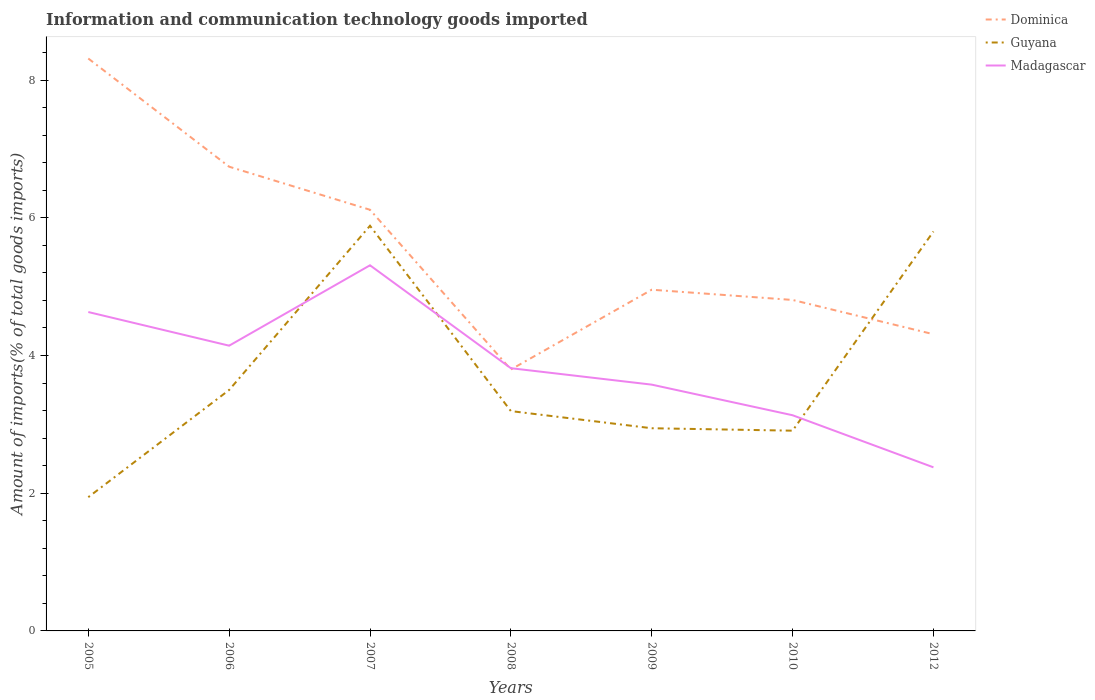How many different coloured lines are there?
Ensure brevity in your answer.  3. Is the number of lines equal to the number of legend labels?
Make the answer very short. Yes. Across all years, what is the maximum amount of goods imported in Madagascar?
Offer a very short reply. 2.38. What is the total amount of goods imported in Madagascar in the graph?
Your answer should be very brief. 1.05. What is the difference between the highest and the second highest amount of goods imported in Guyana?
Make the answer very short. 3.94. What is the difference between the highest and the lowest amount of goods imported in Madagascar?
Keep it short and to the point. 3. How many years are there in the graph?
Provide a short and direct response. 7. What is the difference between two consecutive major ticks on the Y-axis?
Offer a very short reply. 2. Are the values on the major ticks of Y-axis written in scientific E-notation?
Make the answer very short. No. Does the graph contain any zero values?
Provide a short and direct response. No. Does the graph contain grids?
Offer a terse response. No. Where does the legend appear in the graph?
Give a very brief answer. Top right. How are the legend labels stacked?
Offer a terse response. Vertical. What is the title of the graph?
Your answer should be very brief. Information and communication technology goods imported. Does "United States" appear as one of the legend labels in the graph?
Provide a short and direct response. No. What is the label or title of the Y-axis?
Offer a very short reply. Amount of imports(% of total goods imports). What is the Amount of imports(% of total goods imports) of Dominica in 2005?
Offer a terse response. 8.31. What is the Amount of imports(% of total goods imports) in Guyana in 2005?
Give a very brief answer. 1.94. What is the Amount of imports(% of total goods imports) of Madagascar in 2005?
Your answer should be compact. 4.63. What is the Amount of imports(% of total goods imports) of Dominica in 2006?
Make the answer very short. 6.74. What is the Amount of imports(% of total goods imports) in Guyana in 2006?
Offer a very short reply. 3.5. What is the Amount of imports(% of total goods imports) in Madagascar in 2006?
Offer a very short reply. 4.14. What is the Amount of imports(% of total goods imports) in Dominica in 2007?
Offer a very short reply. 6.12. What is the Amount of imports(% of total goods imports) in Guyana in 2007?
Offer a very short reply. 5.88. What is the Amount of imports(% of total goods imports) of Madagascar in 2007?
Your response must be concise. 5.31. What is the Amount of imports(% of total goods imports) of Dominica in 2008?
Keep it short and to the point. 3.8. What is the Amount of imports(% of total goods imports) in Guyana in 2008?
Your response must be concise. 3.19. What is the Amount of imports(% of total goods imports) in Madagascar in 2008?
Provide a succinct answer. 3.82. What is the Amount of imports(% of total goods imports) of Dominica in 2009?
Offer a terse response. 4.95. What is the Amount of imports(% of total goods imports) of Guyana in 2009?
Your answer should be very brief. 2.94. What is the Amount of imports(% of total goods imports) in Madagascar in 2009?
Give a very brief answer. 3.58. What is the Amount of imports(% of total goods imports) in Dominica in 2010?
Provide a succinct answer. 4.81. What is the Amount of imports(% of total goods imports) of Guyana in 2010?
Offer a very short reply. 2.91. What is the Amount of imports(% of total goods imports) in Madagascar in 2010?
Offer a very short reply. 3.13. What is the Amount of imports(% of total goods imports) in Dominica in 2012?
Offer a terse response. 4.31. What is the Amount of imports(% of total goods imports) in Guyana in 2012?
Your response must be concise. 5.8. What is the Amount of imports(% of total goods imports) in Madagascar in 2012?
Make the answer very short. 2.38. Across all years, what is the maximum Amount of imports(% of total goods imports) of Dominica?
Your answer should be very brief. 8.31. Across all years, what is the maximum Amount of imports(% of total goods imports) of Guyana?
Offer a very short reply. 5.88. Across all years, what is the maximum Amount of imports(% of total goods imports) of Madagascar?
Your answer should be very brief. 5.31. Across all years, what is the minimum Amount of imports(% of total goods imports) of Dominica?
Your response must be concise. 3.8. Across all years, what is the minimum Amount of imports(% of total goods imports) of Guyana?
Keep it short and to the point. 1.94. Across all years, what is the minimum Amount of imports(% of total goods imports) of Madagascar?
Offer a terse response. 2.38. What is the total Amount of imports(% of total goods imports) in Dominica in the graph?
Make the answer very short. 39.04. What is the total Amount of imports(% of total goods imports) in Guyana in the graph?
Offer a very short reply. 26.17. What is the total Amount of imports(% of total goods imports) of Madagascar in the graph?
Make the answer very short. 26.98. What is the difference between the Amount of imports(% of total goods imports) in Dominica in 2005 and that in 2006?
Your response must be concise. 1.57. What is the difference between the Amount of imports(% of total goods imports) in Guyana in 2005 and that in 2006?
Keep it short and to the point. -1.56. What is the difference between the Amount of imports(% of total goods imports) in Madagascar in 2005 and that in 2006?
Give a very brief answer. 0.49. What is the difference between the Amount of imports(% of total goods imports) of Dominica in 2005 and that in 2007?
Offer a terse response. 2.2. What is the difference between the Amount of imports(% of total goods imports) in Guyana in 2005 and that in 2007?
Keep it short and to the point. -3.94. What is the difference between the Amount of imports(% of total goods imports) in Madagascar in 2005 and that in 2007?
Make the answer very short. -0.68. What is the difference between the Amount of imports(% of total goods imports) in Dominica in 2005 and that in 2008?
Offer a terse response. 4.52. What is the difference between the Amount of imports(% of total goods imports) in Guyana in 2005 and that in 2008?
Provide a short and direct response. -1.25. What is the difference between the Amount of imports(% of total goods imports) of Madagascar in 2005 and that in 2008?
Offer a very short reply. 0.82. What is the difference between the Amount of imports(% of total goods imports) of Dominica in 2005 and that in 2009?
Ensure brevity in your answer.  3.36. What is the difference between the Amount of imports(% of total goods imports) of Guyana in 2005 and that in 2009?
Provide a succinct answer. -1. What is the difference between the Amount of imports(% of total goods imports) in Madagascar in 2005 and that in 2009?
Your answer should be very brief. 1.05. What is the difference between the Amount of imports(% of total goods imports) in Dominica in 2005 and that in 2010?
Your answer should be very brief. 3.51. What is the difference between the Amount of imports(% of total goods imports) of Guyana in 2005 and that in 2010?
Make the answer very short. -0.97. What is the difference between the Amount of imports(% of total goods imports) of Madagascar in 2005 and that in 2010?
Keep it short and to the point. 1.5. What is the difference between the Amount of imports(% of total goods imports) in Dominica in 2005 and that in 2012?
Your answer should be compact. 4. What is the difference between the Amount of imports(% of total goods imports) in Guyana in 2005 and that in 2012?
Your response must be concise. -3.86. What is the difference between the Amount of imports(% of total goods imports) in Madagascar in 2005 and that in 2012?
Provide a succinct answer. 2.26. What is the difference between the Amount of imports(% of total goods imports) in Dominica in 2006 and that in 2007?
Keep it short and to the point. 0.63. What is the difference between the Amount of imports(% of total goods imports) of Guyana in 2006 and that in 2007?
Make the answer very short. -2.38. What is the difference between the Amount of imports(% of total goods imports) of Madagascar in 2006 and that in 2007?
Make the answer very short. -1.17. What is the difference between the Amount of imports(% of total goods imports) of Dominica in 2006 and that in 2008?
Keep it short and to the point. 2.95. What is the difference between the Amount of imports(% of total goods imports) of Guyana in 2006 and that in 2008?
Your answer should be compact. 0.31. What is the difference between the Amount of imports(% of total goods imports) of Madagascar in 2006 and that in 2008?
Offer a terse response. 0.33. What is the difference between the Amount of imports(% of total goods imports) of Dominica in 2006 and that in 2009?
Keep it short and to the point. 1.79. What is the difference between the Amount of imports(% of total goods imports) of Guyana in 2006 and that in 2009?
Ensure brevity in your answer.  0.56. What is the difference between the Amount of imports(% of total goods imports) in Madagascar in 2006 and that in 2009?
Keep it short and to the point. 0.57. What is the difference between the Amount of imports(% of total goods imports) in Dominica in 2006 and that in 2010?
Your response must be concise. 1.94. What is the difference between the Amount of imports(% of total goods imports) in Guyana in 2006 and that in 2010?
Give a very brief answer. 0.59. What is the difference between the Amount of imports(% of total goods imports) of Madagascar in 2006 and that in 2010?
Ensure brevity in your answer.  1.01. What is the difference between the Amount of imports(% of total goods imports) in Dominica in 2006 and that in 2012?
Offer a terse response. 2.43. What is the difference between the Amount of imports(% of total goods imports) of Guyana in 2006 and that in 2012?
Give a very brief answer. -2.3. What is the difference between the Amount of imports(% of total goods imports) of Madagascar in 2006 and that in 2012?
Provide a succinct answer. 1.77. What is the difference between the Amount of imports(% of total goods imports) in Dominica in 2007 and that in 2008?
Provide a short and direct response. 2.32. What is the difference between the Amount of imports(% of total goods imports) of Guyana in 2007 and that in 2008?
Your response must be concise. 2.69. What is the difference between the Amount of imports(% of total goods imports) in Madagascar in 2007 and that in 2008?
Your response must be concise. 1.49. What is the difference between the Amount of imports(% of total goods imports) in Dominica in 2007 and that in 2009?
Keep it short and to the point. 1.16. What is the difference between the Amount of imports(% of total goods imports) in Guyana in 2007 and that in 2009?
Give a very brief answer. 2.94. What is the difference between the Amount of imports(% of total goods imports) in Madagascar in 2007 and that in 2009?
Make the answer very short. 1.73. What is the difference between the Amount of imports(% of total goods imports) of Dominica in 2007 and that in 2010?
Give a very brief answer. 1.31. What is the difference between the Amount of imports(% of total goods imports) of Guyana in 2007 and that in 2010?
Offer a terse response. 2.98. What is the difference between the Amount of imports(% of total goods imports) of Madagascar in 2007 and that in 2010?
Make the answer very short. 2.18. What is the difference between the Amount of imports(% of total goods imports) of Dominica in 2007 and that in 2012?
Your answer should be very brief. 1.81. What is the difference between the Amount of imports(% of total goods imports) of Guyana in 2007 and that in 2012?
Provide a succinct answer. 0.08. What is the difference between the Amount of imports(% of total goods imports) in Madagascar in 2007 and that in 2012?
Give a very brief answer. 2.93. What is the difference between the Amount of imports(% of total goods imports) of Dominica in 2008 and that in 2009?
Offer a very short reply. -1.16. What is the difference between the Amount of imports(% of total goods imports) of Guyana in 2008 and that in 2009?
Offer a very short reply. 0.25. What is the difference between the Amount of imports(% of total goods imports) of Madagascar in 2008 and that in 2009?
Provide a short and direct response. 0.24. What is the difference between the Amount of imports(% of total goods imports) of Dominica in 2008 and that in 2010?
Give a very brief answer. -1.01. What is the difference between the Amount of imports(% of total goods imports) in Guyana in 2008 and that in 2010?
Make the answer very short. 0.28. What is the difference between the Amount of imports(% of total goods imports) in Madagascar in 2008 and that in 2010?
Provide a succinct answer. 0.68. What is the difference between the Amount of imports(% of total goods imports) in Dominica in 2008 and that in 2012?
Give a very brief answer. -0.51. What is the difference between the Amount of imports(% of total goods imports) of Guyana in 2008 and that in 2012?
Offer a very short reply. -2.61. What is the difference between the Amount of imports(% of total goods imports) in Madagascar in 2008 and that in 2012?
Offer a terse response. 1.44. What is the difference between the Amount of imports(% of total goods imports) in Dominica in 2009 and that in 2010?
Keep it short and to the point. 0.15. What is the difference between the Amount of imports(% of total goods imports) in Guyana in 2009 and that in 2010?
Give a very brief answer. 0.04. What is the difference between the Amount of imports(% of total goods imports) of Madagascar in 2009 and that in 2010?
Keep it short and to the point. 0.44. What is the difference between the Amount of imports(% of total goods imports) of Dominica in 2009 and that in 2012?
Your answer should be compact. 0.65. What is the difference between the Amount of imports(% of total goods imports) in Guyana in 2009 and that in 2012?
Provide a short and direct response. -2.86. What is the difference between the Amount of imports(% of total goods imports) in Madagascar in 2009 and that in 2012?
Give a very brief answer. 1.2. What is the difference between the Amount of imports(% of total goods imports) in Dominica in 2010 and that in 2012?
Offer a very short reply. 0.5. What is the difference between the Amount of imports(% of total goods imports) of Guyana in 2010 and that in 2012?
Make the answer very short. -2.89. What is the difference between the Amount of imports(% of total goods imports) in Madagascar in 2010 and that in 2012?
Give a very brief answer. 0.76. What is the difference between the Amount of imports(% of total goods imports) in Dominica in 2005 and the Amount of imports(% of total goods imports) in Guyana in 2006?
Make the answer very short. 4.81. What is the difference between the Amount of imports(% of total goods imports) of Dominica in 2005 and the Amount of imports(% of total goods imports) of Madagascar in 2006?
Your answer should be compact. 4.17. What is the difference between the Amount of imports(% of total goods imports) of Guyana in 2005 and the Amount of imports(% of total goods imports) of Madagascar in 2006?
Your response must be concise. -2.2. What is the difference between the Amount of imports(% of total goods imports) of Dominica in 2005 and the Amount of imports(% of total goods imports) of Guyana in 2007?
Offer a very short reply. 2.43. What is the difference between the Amount of imports(% of total goods imports) of Dominica in 2005 and the Amount of imports(% of total goods imports) of Madagascar in 2007?
Keep it short and to the point. 3. What is the difference between the Amount of imports(% of total goods imports) in Guyana in 2005 and the Amount of imports(% of total goods imports) in Madagascar in 2007?
Your response must be concise. -3.37. What is the difference between the Amount of imports(% of total goods imports) of Dominica in 2005 and the Amount of imports(% of total goods imports) of Guyana in 2008?
Keep it short and to the point. 5.12. What is the difference between the Amount of imports(% of total goods imports) in Dominica in 2005 and the Amount of imports(% of total goods imports) in Madagascar in 2008?
Provide a succinct answer. 4.5. What is the difference between the Amount of imports(% of total goods imports) of Guyana in 2005 and the Amount of imports(% of total goods imports) of Madagascar in 2008?
Provide a short and direct response. -1.87. What is the difference between the Amount of imports(% of total goods imports) in Dominica in 2005 and the Amount of imports(% of total goods imports) in Guyana in 2009?
Your answer should be compact. 5.37. What is the difference between the Amount of imports(% of total goods imports) in Dominica in 2005 and the Amount of imports(% of total goods imports) in Madagascar in 2009?
Your answer should be compact. 4.74. What is the difference between the Amount of imports(% of total goods imports) of Guyana in 2005 and the Amount of imports(% of total goods imports) of Madagascar in 2009?
Your answer should be compact. -1.63. What is the difference between the Amount of imports(% of total goods imports) of Dominica in 2005 and the Amount of imports(% of total goods imports) of Guyana in 2010?
Make the answer very short. 5.4. What is the difference between the Amount of imports(% of total goods imports) of Dominica in 2005 and the Amount of imports(% of total goods imports) of Madagascar in 2010?
Your answer should be very brief. 5.18. What is the difference between the Amount of imports(% of total goods imports) in Guyana in 2005 and the Amount of imports(% of total goods imports) in Madagascar in 2010?
Make the answer very short. -1.19. What is the difference between the Amount of imports(% of total goods imports) in Dominica in 2005 and the Amount of imports(% of total goods imports) in Guyana in 2012?
Give a very brief answer. 2.51. What is the difference between the Amount of imports(% of total goods imports) of Dominica in 2005 and the Amount of imports(% of total goods imports) of Madagascar in 2012?
Give a very brief answer. 5.94. What is the difference between the Amount of imports(% of total goods imports) in Guyana in 2005 and the Amount of imports(% of total goods imports) in Madagascar in 2012?
Offer a very short reply. -0.43. What is the difference between the Amount of imports(% of total goods imports) in Dominica in 2006 and the Amount of imports(% of total goods imports) in Guyana in 2007?
Make the answer very short. 0.86. What is the difference between the Amount of imports(% of total goods imports) of Dominica in 2006 and the Amount of imports(% of total goods imports) of Madagascar in 2007?
Your answer should be compact. 1.43. What is the difference between the Amount of imports(% of total goods imports) in Guyana in 2006 and the Amount of imports(% of total goods imports) in Madagascar in 2007?
Give a very brief answer. -1.81. What is the difference between the Amount of imports(% of total goods imports) of Dominica in 2006 and the Amount of imports(% of total goods imports) of Guyana in 2008?
Your answer should be very brief. 3.55. What is the difference between the Amount of imports(% of total goods imports) in Dominica in 2006 and the Amount of imports(% of total goods imports) in Madagascar in 2008?
Ensure brevity in your answer.  2.93. What is the difference between the Amount of imports(% of total goods imports) in Guyana in 2006 and the Amount of imports(% of total goods imports) in Madagascar in 2008?
Give a very brief answer. -0.32. What is the difference between the Amount of imports(% of total goods imports) in Dominica in 2006 and the Amount of imports(% of total goods imports) in Guyana in 2009?
Keep it short and to the point. 3.8. What is the difference between the Amount of imports(% of total goods imports) in Dominica in 2006 and the Amount of imports(% of total goods imports) in Madagascar in 2009?
Your answer should be very brief. 3.16. What is the difference between the Amount of imports(% of total goods imports) of Guyana in 2006 and the Amount of imports(% of total goods imports) of Madagascar in 2009?
Offer a terse response. -0.08. What is the difference between the Amount of imports(% of total goods imports) of Dominica in 2006 and the Amount of imports(% of total goods imports) of Guyana in 2010?
Give a very brief answer. 3.83. What is the difference between the Amount of imports(% of total goods imports) in Dominica in 2006 and the Amount of imports(% of total goods imports) in Madagascar in 2010?
Ensure brevity in your answer.  3.61. What is the difference between the Amount of imports(% of total goods imports) of Guyana in 2006 and the Amount of imports(% of total goods imports) of Madagascar in 2010?
Give a very brief answer. 0.37. What is the difference between the Amount of imports(% of total goods imports) of Dominica in 2006 and the Amount of imports(% of total goods imports) of Guyana in 2012?
Offer a very short reply. 0.94. What is the difference between the Amount of imports(% of total goods imports) in Dominica in 2006 and the Amount of imports(% of total goods imports) in Madagascar in 2012?
Offer a very short reply. 4.37. What is the difference between the Amount of imports(% of total goods imports) of Guyana in 2006 and the Amount of imports(% of total goods imports) of Madagascar in 2012?
Your answer should be very brief. 1.12. What is the difference between the Amount of imports(% of total goods imports) in Dominica in 2007 and the Amount of imports(% of total goods imports) in Guyana in 2008?
Offer a terse response. 2.92. What is the difference between the Amount of imports(% of total goods imports) in Dominica in 2007 and the Amount of imports(% of total goods imports) in Madagascar in 2008?
Make the answer very short. 2.3. What is the difference between the Amount of imports(% of total goods imports) of Guyana in 2007 and the Amount of imports(% of total goods imports) of Madagascar in 2008?
Ensure brevity in your answer.  2.07. What is the difference between the Amount of imports(% of total goods imports) of Dominica in 2007 and the Amount of imports(% of total goods imports) of Guyana in 2009?
Offer a very short reply. 3.17. What is the difference between the Amount of imports(% of total goods imports) in Dominica in 2007 and the Amount of imports(% of total goods imports) in Madagascar in 2009?
Provide a succinct answer. 2.54. What is the difference between the Amount of imports(% of total goods imports) in Guyana in 2007 and the Amount of imports(% of total goods imports) in Madagascar in 2009?
Offer a very short reply. 2.31. What is the difference between the Amount of imports(% of total goods imports) in Dominica in 2007 and the Amount of imports(% of total goods imports) in Guyana in 2010?
Make the answer very short. 3.21. What is the difference between the Amount of imports(% of total goods imports) in Dominica in 2007 and the Amount of imports(% of total goods imports) in Madagascar in 2010?
Make the answer very short. 2.98. What is the difference between the Amount of imports(% of total goods imports) of Guyana in 2007 and the Amount of imports(% of total goods imports) of Madagascar in 2010?
Ensure brevity in your answer.  2.75. What is the difference between the Amount of imports(% of total goods imports) in Dominica in 2007 and the Amount of imports(% of total goods imports) in Guyana in 2012?
Provide a short and direct response. 0.32. What is the difference between the Amount of imports(% of total goods imports) in Dominica in 2007 and the Amount of imports(% of total goods imports) in Madagascar in 2012?
Make the answer very short. 3.74. What is the difference between the Amount of imports(% of total goods imports) of Guyana in 2007 and the Amount of imports(% of total goods imports) of Madagascar in 2012?
Your answer should be compact. 3.51. What is the difference between the Amount of imports(% of total goods imports) of Dominica in 2008 and the Amount of imports(% of total goods imports) of Guyana in 2009?
Keep it short and to the point. 0.85. What is the difference between the Amount of imports(% of total goods imports) of Dominica in 2008 and the Amount of imports(% of total goods imports) of Madagascar in 2009?
Provide a short and direct response. 0.22. What is the difference between the Amount of imports(% of total goods imports) of Guyana in 2008 and the Amount of imports(% of total goods imports) of Madagascar in 2009?
Keep it short and to the point. -0.38. What is the difference between the Amount of imports(% of total goods imports) of Dominica in 2008 and the Amount of imports(% of total goods imports) of Guyana in 2010?
Make the answer very short. 0.89. What is the difference between the Amount of imports(% of total goods imports) in Dominica in 2008 and the Amount of imports(% of total goods imports) in Madagascar in 2010?
Provide a short and direct response. 0.66. What is the difference between the Amount of imports(% of total goods imports) of Guyana in 2008 and the Amount of imports(% of total goods imports) of Madagascar in 2010?
Offer a very short reply. 0.06. What is the difference between the Amount of imports(% of total goods imports) of Dominica in 2008 and the Amount of imports(% of total goods imports) of Guyana in 2012?
Give a very brief answer. -2. What is the difference between the Amount of imports(% of total goods imports) of Dominica in 2008 and the Amount of imports(% of total goods imports) of Madagascar in 2012?
Ensure brevity in your answer.  1.42. What is the difference between the Amount of imports(% of total goods imports) of Guyana in 2008 and the Amount of imports(% of total goods imports) of Madagascar in 2012?
Offer a terse response. 0.82. What is the difference between the Amount of imports(% of total goods imports) of Dominica in 2009 and the Amount of imports(% of total goods imports) of Guyana in 2010?
Your answer should be compact. 2.05. What is the difference between the Amount of imports(% of total goods imports) of Dominica in 2009 and the Amount of imports(% of total goods imports) of Madagascar in 2010?
Keep it short and to the point. 1.82. What is the difference between the Amount of imports(% of total goods imports) of Guyana in 2009 and the Amount of imports(% of total goods imports) of Madagascar in 2010?
Offer a very short reply. -0.19. What is the difference between the Amount of imports(% of total goods imports) of Dominica in 2009 and the Amount of imports(% of total goods imports) of Guyana in 2012?
Your response must be concise. -0.85. What is the difference between the Amount of imports(% of total goods imports) of Dominica in 2009 and the Amount of imports(% of total goods imports) of Madagascar in 2012?
Your answer should be very brief. 2.58. What is the difference between the Amount of imports(% of total goods imports) of Guyana in 2009 and the Amount of imports(% of total goods imports) of Madagascar in 2012?
Give a very brief answer. 0.57. What is the difference between the Amount of imports(% of total goods imports) of Dominica in 2010 and the Amount of imports(% of total goods imports) of Guyana in 2012?
Provide a short and direct response. -0.99. What is the difference between the Amount of imports(% of total goods imports) of Dominica in 2010 and the Amount of imports(% of total goods imports) of Madagascar in 2012?
Ensure brevity in your answer.  2.43. What is the difference between the Amount of imports(% of total goods imports) in Guyana in 2010 and the Amount of imports(% of total goods imports) in Madagascar in 2012?
Provide a succinct answer. 0.53. What is the average Amount of imports(% of total goods imports) of Dominica per year?
Your answer should be compact. 5.58. What is the average Amount of imports(% of total goods imports) in Guyana per year?
Keep it short and to the point. 3.74. What is the average Amount of imports(% of total goods imports) of Madagascar per year?
Offer a very short reply. 3.85. In the year 2005, what is the difference between the Amount of imports(% of total goods imports) in Dominica and Amount of imports(% of total goods imports) in Guyana?
Provide a succinct answer. 6.37. In the year 2005, what is the difference between the Amount of imports(% of total goods imports) of Dominica and Amount of imports(% of total goods imports) of Madagascar?
Your answer should be compact. 3.68. In the year 2005, what is the difference between the Amount of imports(% of total goods imports) in Guyana and Amount of imports(% of total goods imports) in Madagascar?
Offer a terse response. -2.69. In the year 2006, what is the difference between the Amount of imports(% of total goods imports) in Dominica and Amount of imports(% of total goods imports) in Guyana?
Your answer should be compact. 3.24. In the year 2006, what is the difference between the Amount of imports(% of total goods imports) of Dominica and Amount of imports(% of total goods imports) of Madagascar?
Ensure brevity in your answer.  2.6. In the year 2006, what is the difference between the Amount of imports(% of total goods imports) in Guyana and Amount of imports(% of total goods imports) in Madagascar?
Provide a short and direct response. -0.64. In the year 2007, what is the difference between the Amount of imports(% of total goods imports) of Dominica and Amount of imports(% of total goods imports) of Guyana?
Your answer should be compact. 0.23. In the year 2007, what is the difference between the Amount of imports(% of total goods imports) in Dominica and Amount of imports(% of total goods imports) in Madagascar?
Keep it short and to the point. 0.81. In the year 2007, what is the difference between the Amount of imports(% of total goods imports) of Guyana and Amount of imports(% of total goods imports) of Madagascar?
Make the answer very short. 0.57. In the year 2008, what is the difference between the Amount of imports(% of total goods imports) in Dominica and Amount of imports(% of total goods imports) in Guyana?
Your answer should be compact. 0.6. In the year 2008, what is the difference between the Amount of imports(% of total goods imports) in Dominica and Amount of imports(% of total goods imports) in Madagascar?
Provide a short and direct response. -0.02. In the year 2008, what is the difference between the Amount of imports(% of total goods imports) in Guyana and Amount of imports(% of total goods imports) in Madagascar?
Offer a terse response. -0.62. In the year 2009, what is the difference between the Amount of imports(% of total goods imports) in Dominica and Amount of imports(% of total goods imports) in Guyana?
Make the answer very short. 2.01. In the year 2009, what is the difference between the Amount of imports(% of total goods imports) of Dominica and Amount of imports(% of total goods imports) of Madagascar?
Your answer should be compact. 1.38. In the year 2009, what is the difference between the Amount of imports(% of total goods imports) of Guyana and Amount of imports(% of total goods imports) of Madagascar?
Your answer should be compact. -0.63. In the year 2010, what is the difference between the Amount of imports(% of total goods imports) in Dominica and Amount of imports(% of total goods imports) in Guyana?
Make the answer very short. 1.9. In the year 2010, what is the difference between the Amount of imports(% of total goods imports) of Dominica and Amount of imports(% of total goods imports) of Madagascar?
Keep it short and to the point. 1.67. In the year 2010, what is the difference between the Amount of imports(% of total goods imports) in Guyana and Amount of imports(% of total goods imports) in Madagascar?
Keep it short and to the point. -0.22. In the year 2012, what is the difference between the Amount of imports(% of total goods imports) in Dominica and Amount of imports(% of total goods imports) in Guyana?
Ensure brevity in your answer.  -1.49. In the year 2012, what is the difference between the Amount of imports(% of total goods imports) in Dominica and Amount of imports(% of total goods imports) in Madagascar?
Your response must be concise. 1.93. In the year 2012, what is the difference between the Amount of imports(% of total goods imports) in Guyana and Amount of imports(% of total goods imports) in Madagascar?
Provide a short and direct response. 3.42. What is the ratio of the Amount of imports(% of total goods imports) in Dominica in 2005 to that in 2006?
Keep it short and to the point. 1.23. What is the ratio of the Amount of imports(% of total goods imports) of Guyana in 2005 to that in 2006?
Your answer should be compact. 0.56. What is the ratio of the Amount of imports(% of total goods imports) of Madagascar in 2005 to that in 2006?
Provide a short and direct response. 1.12. What is the ratio of the Amount of imports(% of total goods imports) of Dominica in 2005 to that in 2007?
Your response must be concise. 1.36. What is the ratio of the Amount of imports(% of total goods imports) in Guyana in 2005 to that in 2007?
Make the answer very short. 0.33. What is the ratio of the Amount of imports(% of total goods imports) of Madagascar in 2005 to that in 2007?
Provide a short and direct response. 0.87. What is the ratio of the Amount of imports(% of total goods imports) of Dominica in 2005 to that in 2008?
Keep it short and to the point. 2.19. What is the ratio of the Amount of imports(% of total goods imports) in Guyana in 2005 to that in 2008?
Provide a succinct answer. 0.61. What is the ratio of the Amount of imports(% of total goods imports) of Madagascar in 2005 to that in 2008?
Your answer should be very brief. 1.21. What is the ratio of the Amount of imports(% of total goods imports) of Dominica in 2005 to that in 2009?
Offer a very short reply. 1.68. What is the ratio of the Amount of imports(% of total goods imports) in Guyana in 2005 to that in 2009?
Provide a succinct answer. 0.66. What is the ratio of the Amount of imports(% of total goods imports) in Madagascar in 2005 to that in 2009?
Keep it short and to the point. 1.29. What is the ratio of the Amount of imports(% of total goods imports) of Dominica in 2005 to that in 2010?
Ensure brevity in your answer.  1.73. What is the ratio of the Amount of imports(% of total goods imports) of Guyana in 2005 to that in 2010?
Your response must be concise. 0.67. What is the ratio of the Amount of imports(% of total goods imports) of Madagascar in 2005 to that in 2010?
Give a very brief answer. 1.48. What is the ratio of the Amount of imports(% of total goods imports) of Dominica in 2005 to that in 2012?
Give a very brief answer. 1.93. What is the ratio of the Amount of imports(% of total goods imports) in Guyana in 2005 to that in 2012?
Offer a terse response. 0.33. What is the ratio of the Amount of imports(% of total goods imports) of Madagascar in 2005 to that in 2012?
Keep it short and to the point. 1.95. What is the ratio of the Amount of imports(% of total goods imports) in Dominica in 2006 to that in 2007?
Offer a very short reply. 1.1. What is the ratio of the Amount of imports(% of total goods imports) in Guyana in 2006 to that in 2007?
Your response must be concise. 0.59. What is the ratio of the Amount of imports(% of total goods imports) in Madagascar in 2006 to that in 2007?
Make the answer very short. 0.78. What is the ratio of the Amount of imports(% of total goods imports) of Dominica in 2006 to that in 2008?
Your answer should be very brief. 1.78. What is the ratio of the Amount of imports(% of total goods imports) in Guyana in 2006 to that in 2008?
Offer a very short reply. 1.1. What is the ratio of the Amount of imports(% of total goods imports) in Madagascar in 2006 to that in 2008?
Give a very brief answer. 1.09. What is the ratio of the Amount of imports(% of total goods imports) of Dominica in 2006 to that in 2009?
Your answer should be very brief. 1.36. What is the ratio of the Amount of imports(% of total goods imports) in Guyana in 2006 to that in 2009?
Offer a terse response. 1.19. What is the ratio of the Amount of imports(% of total goods imports) in Madagascar in 2006 to that in 2009?
Your response must be concise. 1.16. What is the ratio of the Amount of imports(% of total goods imports) in Dominica in 2006 to that in 2010?
Your answer should be compact. 1.4. What is the ratio of the Amount of imports(% of total goods imports) of Guyana in 2006 to that in 2010?
Offer a very short reply. 1.2. What is the ratio of the Amount of imports(% of total goods imports) of Madagascar in 2006 to that in 2010?
Ensure brevity in your answer.  1.32. What is the ratio of the Amount of imports(% of total goods imports) in Dominica in 2006 to that in 2012?
Your response must be concise. 1.56. What is the ratio of the Amount of imports(% of total goods imports) in Guyana in 2006 to that in 2012?
Provide a short and direct response. 0.6. What is the ratio of the Amount of imports(% of total goods imports) in Madagascar in 2006 to that in 2012?
Offer a terse response. 1.74. What is the ratio of the Amount of imports(% of total goods imports) in Dominica in 2007 to that in 2008?
Offer a very short reply. 1.61. What is the ratio of the Amount of imports(% of total goods imports) in Guyana in 2007 to that in 2008?
Offer a terse response. 1.84. What is the ratio of the Amount of imports(% of total goods imports) in Madagascar in 2007 to that in 2008?
Offer a terse response. 1.39. What is the ratio of the Amount of imports(% of total goods imports) in Dominica in 2007 to that in 2009?
Ensure brevity in your answer.  1.23. What is the ratio of the Amount of imports(% of total goods imports) of Guyana in 2007 to that in 2009?
Provide a short and direct response. 2. What is the ratio of the Amount of imports(% of total goods imports) in Madagascar in 2007 to that in 2009?
Give a very brief answer. 1.48. What is the ratio of the Amount of imports(% of total goods imports) of Dominica in 2007 to that in 2010?
Offer a terse response. 1.27. What is the ratio of the Amount of imports(% of total goods imports) in Guyana in 2007 to that in 2010?
Your answer should be very brief. 2.02. What is the ratio of the Amount of imports(% of total goods imports) in Madagascar in 2007 to that in 2010?
Offer a terse response. 1.7. What is the ratio of the Amount of imports(% of total goods imports) in Dominica in 2007 to that in 2012?
Your answer should be very brief. 1.42. What is the ratio of the Amount of imports(% of total goods imports) in Guyana in 2007 to that in 2012?
Your answer should be compact. 1.01. What is the ratio of the Amount of imports(% of total goods imports) of Madagascar in 2007 to that in 2012?
Your response must be concise. 2.23. What is the ratio of the Amount of imports(% of total goods imports) in Dominica in 2008 to that in 2009?
Your response must be concise. 0.77. What is the ratio of the Amount of imports(% of total goods imports) of Guyana in 2008 to that in 2009?
Offer a terse response. 1.08. What is the ratio of the Amount of imports(% of total goods imports) in Madagascar in 2008 to that in 2009?
Offer a very short reply. 1.07. What is the ratio of the Amount of imports(% of total goods imports) of Dominica in 2008 to that in 2010?
Make the answer very short. 0.79. What is the ratio of the Amount of imports(% of total goods imports) of Guyana in 2008 to that in 2010?
Keep it short and to the point. 1.1. What is the ratio of the Amount of imports(% of total goods imports) in Madagascar in 2008 to that in 2010?
Offer a very short reply. 1.22. What is the ratio of the Amount of imports(% of total goods imports) of Dominica in 2008 to that in 2012?
Keep it short and to the point. 0.88. What is the ratio of the Amount of imports(% of total goods imports) in Guyana in 2008 to that in 2012?
Provide a succinct answer. 0.55. What is the ratio of the Amount of imports(% of total goods imports) of Madagascar in 2008 to that in 2012?
Provide a short and direct response. 1.61. What is the ratio of the Amount of imports(% of total goods imports) of Dominica in 2009 to that in 2010?
Your answer should be compact. 1.03. What is the ratio of the Amount of imports(% of total goods imports) in Guyana in 2009 to that in 2010?
Ensure brevity in your answer.  1.01. What is the ratio of the Amount of imports(% of total goods imports) of Madagascar in 2009 to that in 2010?
Give a very brief answer. 1.14. What is the ratio of the Amount of imports(% of total goods imports) in Dominica in 2009 to that in 2012?
Keep it short and to the point. 1.15. What is the ratio of the Amount of imports(% of total goods imports) in Guyana in 2009 to that in 2012?
Your answer should be compact. 0.51. What is the ratio of the Amount of imports(% of total goods imports) in Madagascar in 2009 to that in 2012?
Make the answer very short. 1.51. What is the ratio of the Amount of imports(% of total goods imports) in Dominica in 2010 to that in 2012?
Provide a succinct answer. 1.12. What is the ratio of the Amount of imports(% of total goods imports) of Guyana in 2010 to that in 2012?
Ensure brevity in your answer.  0.5. What is the ratio of the Amount of imports(% of total goods imports) in Madagascar in 2010 to that in 2012?
Provide a succinct answer. 1.32. What is the difference between the highest and the second highest Amount of imports(% of total goods imports) of Dominica?
Offer a terse response. 1.57. What is the difference between the highest and the second highest Amount of imports(% of total goods imports) of Guyana?
Ensure brevity in your answer.  0.08. What is the difference between the highest and the second highest Amount of imports(% of total goods imports) in Madagascar?
Make the answer very short. 0.68. What is the difference between the highest and the lowest Amount of imports(% of total goods imports) of Dominica?
Keep it short and to the point. 4.52. What is the difference between the highest and the lowest Amount of imports(% of total goods imports) in Guyana?
Your answer should be very brief. 3.94. What is the difference between the highest and the lowest Amount of imports(% of total goods imports) in Madagascar?
Your answer should be very brief. 2.93. 